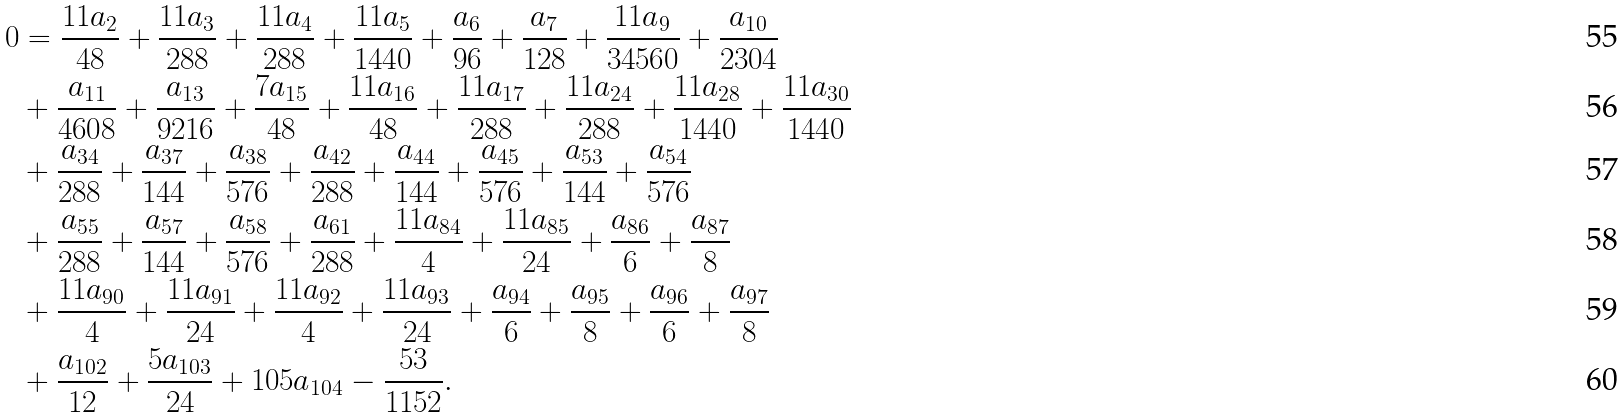<formula> <loc_0><loc_0><loc_500><loc_500>0 & = \frac { 1 1 a _ { 2 } } { 4 8 } + \frac { 1 1 a _ { 3 } } { 2 8 8 } + \frac { 1 1 a _ { 4 } } { 2 8 8 } + \frac { 1 1 a _ { 5 } } { 1 4 4 0 } + \frac { a _ { 6 } } { 9 6 } + \frac { a _ { 7 } } { 1 2 8 } + \frac { 1 1 a _ { 9 } } { 3 4 5 6 0 } + \frac { a _ { 1 0 } } { 2 3 0 4 } \\ & + \frac { a _ { 1 1 } } { 4 6 0 8 } + \frac { a _ { 1 3 } } { 9 2 1 6 } + \frac { 7 a _ { 1 5 } } { 4 8 } + \frac { 1 1 a _ { 1 6 } } { 4 8 } + \frac { 1 1 a _ { 1 7 } } { 2 8 8 } + \frac { 1 1 a _ { 2 4 } } { 2 8 8 } + \frac { 1 1 a _ { 2 8 } } { 1 4 4 0 } + \frac { 1 1 a _ { 3 0 } } { 1 4 4 0 } \\ & + \frac { a _ { 3 4 } } { 2 8 8 } + \frac { a _ { 3 7 } } { 1 4 4 } + \frac { a _ { 3 8 } } { 5 7 6 } + \frac { a _ { 4 2 } } { 2 8 8 } + \frac { a _ { 4 4 } } { 1 4 4 } + \frac { a _ { 4 5 } } { 5 7 6 } + \frac { a _ { 5 3 } } { 1 4 4 } + \frac { a _ { 5 4 } } { 5 7 6 } \\ & + \frac { a _ { 5 5 } } { 2 8 8 } + \frac { a _ { 5 7 } } { 1 4 4 } + \frac { a _ { 5 8 } } { 5 7 6 } + \frac { a _ { 6 1 } } { 2 8 8 } + \frac { 1 1 a _ { 8 4 } } { 4 } + \frac { 1 1 a _ { 8 5 } } { 2 4 } + \frac { a _ { 8 6 } } { 6 } + \frac { a _ { 8 7 } } { 8 } \\ & + \frac { 1 1 a _ { 9 0 } } { 4 } + \frac { 1 1 a _ { 9 1 } } { 2 4 } + \frac { 1 1 a _ { 9 2 } } { 4 } + \frac { 1 1 a _ { 9 3 } } { 2 4 } + \frac { a _ { 9 4 } } { 6 } + \frac { a _ { 9 5 } } { 8 } + \frac { a _ { 9 6 } } { 6 } + \frac { a _ { 9 7 } } { 8 } \\ & + \frac { a _ { 1 0 2 } } { 1 2 } + \frac { 5 a _ { 1 0 3 } } { 2 4 } + 1 0 5 a _ { 1 0 4 } - \frac { 5 3 } { 1 1 5 2 } .</formula> 